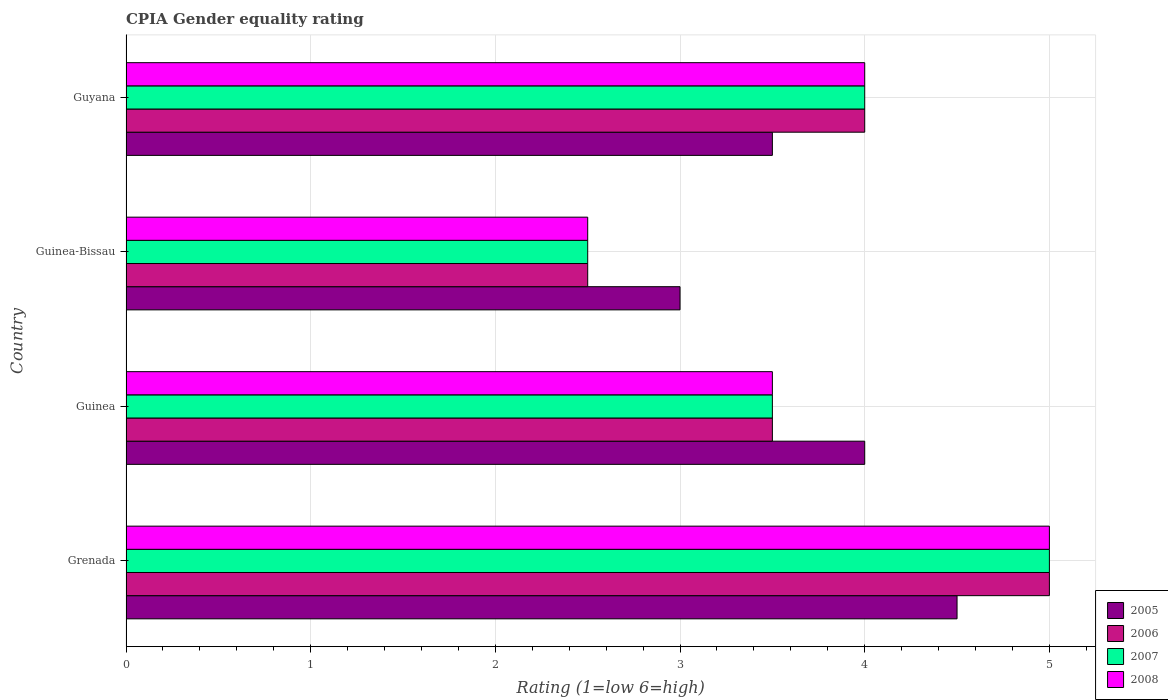How many different coloured bars are there?
Offer a very short reply. 4. How many groups of bars are there?
Ensure brevity in your answer.  4. How many bars are there on the 2nd tick from the bottom?
Make the answer very short. 4. What is the label of the 4th group of bars from the top?
Offer a terse response. Grenada. Across all countries, what is the maximum CPIA rating in 2005?
Make the answer very short. 4.5. In which country was the CPIA rating in 2005 maximum?
Offer a very short reply. Grenada. In which country was the CPIA rating in 2007 minimum?
Give a very brief answer. Guinea-Bissau. What is the total CPIA rating in 2005 in the graph?
Offer a terse response. 15. What is the average CPIA rating in 2007 per country?
Offer a terse response. 3.75. What is the difference between the CPIA rating in 2005 and CPIA rating in 2006 in Guinea?
Ensure brevity in your answer.  0.5. In how many countries, is the CPIA rating in 2006 greater than 1 ?
Offer a terse response. 4. Is the difference between the CPIA rating in 2005 in Grenada and Guinea greater than the difference between the CPIA rating in 2006 in Grenada and Guinea?
Provide a succinct answer. No. What is the difference between the highest and the second highest CPIA rating in 2008?
Your response must be concise. 1. What is the difference between the highest and the lowest CPIA rating in 2006?
Your answer should be very brief. 2.5. In how many countries, is the CPIA rating in 2008 greater than the average CPIA rating in 2008 taken over all countries?
Offer a terse response. 2. What does the 3rd bar from the top in Guinea represents?
Provide a succinct answer. 2006. What does the 1st bar from the bottom in Guinea-Bissau represents?
Make the answer very short. 2005. Is it the case that in every country, the sum of the CPIA rating in 2008 and CPIA rating in 2005 is greater than the CPIA rating in 2006?
Provide a succinct answer. Yes. How many bars are there?
Ensure brevity in your answer.  16. Are all the bars in the graph horizontal?
Keep it short and to the point. Yes. How many countries are there in the graph?
Your answer should be very brief. 4. Does the graph contain any zero values?
Offer a terse response. No. Does the graph contain grids?
Provide a short and direct response. Yes. Where does the legend appear in the graph?
Make the answer very short. Bottom right. How are the legend labels stacked?
Ensure brevity in your answer.  Vertical. What is the title of the graph?
Your response must be concise. CPIA Gender equality rating. Does "2007" appear as one of the legend labels in the graph?
Ensure brevity in your answer.  Yes. What is the label or title of the X-axis?
Ensure brevity in your answer.  Rating (1=low 6=high). What is the Rating (1=low 6=high) of 2007 in Grenada?
Give a very brief answer. 5. What is the Rating (1=low 6=high) in 2008 in Grenada?
Keep it short and to the point. 5. What is the Rating (1=low 6=high) of 2007 in Guinea?
Ensure brevity in your answer.  3.5. What is the Rating (1=low 6=high) of 2008 in Guinea?
Offer a terse response. 3.5. What is the Rating (1=low 6=high) in 2005 in Guinea-Bissau?
Ensure brevity in your answer.  3. What is the Rating (1=low 6=high) in 2006 in Guinea-Bissau?
Keep it short and to the point. 2.5. What is the Rating (1=low 6=high) in 2006 in Guyana?
Provide a succinct answer. 4. Across all countries, what is the maximum Rating (1=low 6=high) of 2006?
Your answer should be very brief. 5. Across all countries, what is the maximum Rating (1=low 6=high) of 2007?
Provide a succinct answer. 5. Across all countries, what is the maximum Rating (1=low 6=high) of 2008?
Give a very brief answer. 5. Across all countries, what is the minimum Rating (1=low 6=high) of 2006?
Your answer should be compact. 2.5. Across all countries, what is the minimum Rating (1=low 6=high) in 2007?
Offer a terse response. 2.5. What is the total Rating (1=low 6=high) in 2005 in the graph?
Keep it short and to the point. 15. What is the total Rating (1=low 6=high) of 2006 in the graph?
Your answer should be compact. 15. What is the total Rating (1=low 6=high) of 2007 in the graph?
Give a very brief answer. 15. What is the difference between the Rating (1=low 6=high) of 2005 in Grenada and that in Guinea?
Ensure brevity in your answer.  0.5. What is the difference between the Rating (1=low 6=high) of 2006 in Grenada and that in Guinea?
Give a very brief answer. 1.5. What is the difference between the Rating (1=low 6=high) in 2005 in Grenada and that in Guyana?
Give a very brief answer. 1. What is the difference between the Rating (1=low 6=high) of 2007 in Grenada and that in Guyana?
Offer a terse response. 1. What is the difference between the Rating (1=low 6=high) of 2005 in Guinea and that in Guinea-Bissau?
Offer a very short reply. 1. What is the difference between the Rating (1=low 6=high) of 2006 in Guinea and that in Guinea-Bissau?
Provide a short and direct response. 1. What is the difference between the Rating (1=low 6=high) of 2007 in Guinea and that in Guinea-Bissau?
Give a very brief answer. 1. What is the difference between the Rating (1=low 6=high) of 2008 in Guinea and that in Guinea-Bissau?
Offer a very short reply. 1. What is the difference between the Rating (1=low 6=high) of 2007 in Guinea and that in Guyana?
Offer a very short reply. -0.5. What is the difference between the Rating (1=low 6=high) of 2005 in Guinea-Bissau and that in Guyana?
Offer a terse response. -0.5. What is the difference between the Rating (1=low 6=high) of 2007 in Guinea-Bissau and that in Guyana?
Your answer should be very brief. -1.5. What is the difference between the Rating (1=low 6=high) in 2008 in Guinea-Bissau and that in Guyana?
Your answer should be compact. -1.5. What is the difference between the Rating (1=low 6=high) in 2005 in Grenada and the Rating (1=low 6=high) in 2006 in Guinea?
Offer a very short reply. 1. What is the difference between the Rating (1=low 6=high) of 2005 in Grenada and the Rating (1=low 6=high) of 2007 in Guinea?
Give a very brief answer. 1. What is the difference between the Rating (1=low 6=high) in 2007 in Grenada and the Rating (1=low 6=high) in 2008 in Guinea?
Offer a terse response. 1.5. What is the difference between the Rating (1=low 6=high) of 2006 in Grenada and the Rating (1=low 6=high) of 2008 in Guinea-Bissau?
Your answer should be compact. 2.5. What is the difference between the Rating (1=low 6=high) in 2005 in Grenada and the Rating (1=low 6=high) in 2006 in Guyana?
Give a very brief answer. 0.5. What is the difference between the Rating (1=low 6=high) of 2006 in Grenada and the Rating (1=low 6=high) of 2007 in Guyana?
Offer a very short reply. 1. What is the difference between the Rating (1=low 6=high) in 2006 in Grenada and the Rating (1=low 6=high) in 2008 in Guyana?
Offer a very short reply. 1. What is the difference between the Rating (1=low 6=high) in 2005 in Guinea and the Rating (1=low 6=high) in 2006 in Guinea-Bissau?
Your response must be concise. 1.5. What is the difference between the Rating (1=low 6=high) in 2005 in Guinea and the Rating (1=low 6=high) in 2007 in Guinea-Bissau?
Give a very brief answer. 1.5. What is the difference between the Rating (1=low 6=high) in 2006 in Guinea and the Rating (1=low 6=high) in 2008 in Guinea-Bissau?
Provide a succinct answer. 1. What is the difference between the Rating (1=low 6=high) of 2005 in Guinea and the Rating (1=low 6=high) of 2006 in Guyana?
Provide a succinct answer. 0. What is the difference between the Rating (1=low 6=high) in 2005 in Guinea and the Rating (1=low 6=high) in 2007 in Guyana?
Provide a succinct answer. 0. What is the difference between the Rating (1=low 6=high) in 2005 in Guinea and the Rating (1=low 6=high) in 2008 in Guyana?
Make the answer very short. 0. What is the difference between the Rating (1=low 6=high) in 2005 in Guinea-Bissau and the Rating (1=low 6=high) in 2006 in Guyana?
Give a very brief answer. -1. What is the difference between the Rating (1=low 6=high) in 2005 in Guinea-Bissau and the Rating (1=low 6=high) in 2007 in Guyana?
Offer a very short reply. -1. What is the difference between the Rating (1=low 6=high) in 2005 in Guinea-Bissau and the Rating (1=low 6=high) in 2008 in Guyana?
Give a very brief answer. -1. What is the difference between the Rating (1=low 6=high) in 2007 in Guinea-Bissau and the Rating (1=low 6=high) in 2008 in Guyana?
Make the answer very short. -1.5. What is the average Rating (1=low 6=high) of 2005 per country?
Offer a terse response. 3.75. What is the average Rating (1=low 6=high) of 2006 per country?
Provide a succinct answer. 3.75. What is the average Rating (1=low 6=high) of 2007 per country?
Your response must be concise. 3.75. What is the average Rating (1=low 6=high) of 2008 per country?
Give a very brief answer. 3.75. What is the difference between the Rating (1=low 6=high) in 2005 and Rating (1=low 6=high) in 2006 in Grenada?
Offer a terse response. -0.5. What is the difference between the Rating (1=low 6=high) of 2007 and Rating (1=low 6=high) of 2008 in Grenada?
Make the answer very short. 0. What is the difference between the Rating (1=low 6=high) in 2005 and Rating (1=low 6=high) in 2007 in Guinea?
Ensure brevity in your answer.  0.5. What is the difference between the Rating (1=low 6=high) in 2006 and Rating (1=low 6=high) in 2007 in Guinea?
Offer a very short reply. 0. What is the difference between the Rating (1=low 6=high) in 2006 and Rating (1=low 6=high) in 2008 in Guinea?
Provide a short and direct response. 0. What is the difference between the Rating (1=low 6=high) of 2005 and Rating (1=low 6=high) of 2007 in Guinea-Bissau?
Offer a terse response. 0.5. What is the difference between the Rating (1=low 6=high) of 2006 and Rating (1=low 6=high) of 2007 in Guinea-Bissau?
Your answer should be very brief. 0. What is the difference between the Rating (1=low 6=high) of 2005 and Rating (1=low 6=high) of 2006 in Guyana?
Ensure brevity in your answer.  -0.5. What is the difference between the Rating (1=low 6=high) in 2006 and Rating (1=low 6=high) in 2007 in Guyana?
Your response must be concise. 0. What is the ratio of the Rating (1=low 6=high) in 2005 in Grenada to that in Guinea?
Provide a succinct answer. 1.12. What is the ratio of the Rating (1=low 6=high) in 2006 in Grenada to that in Guinea?
Your answer should be very brief. 1.43. What is the ratio of the Rating (1=low 6=high) in 2007 in Grenada to that in Guinea?
Offer a terse response. 1.43. What is the ratio of the Rating (1=low 6=high) in 2008 in Grenada to that in Guinea?
Ensure brevity in your answer.  1.43. What is the ratio of the Rating (1=low 6=high) of 2005 in Grenada to that in Guinea-Bissau?
Offer a very short reply. 1.5. What is the ratio of the Rating (1=low 6=high) of 2007 in Grenada to that in Guinea-Bissau?
Your answer should be compact. 2. What is the ratio of the Rating (1=low 6=high) of 2008 in Grenada to that in Guinea-Bissau?
Offer a very short reply. 2. What is the ratio of the Rating (1=low 6=high) in 2005 in Grenada to that in Guyana?
Provide a short and direct response. 1.29. What is the ratio of the Rating (1=low 6=high) in 2006 in Grenada to that in Guyana?
Provide a short and direct response. 1.25. What is the ratio of the Rating (1=low 6=high) in 2005 in Guinea to that in Guinea-Bissau?
Your response must be concise. 1.33. What is the ratio of the Rating (1=low 6=high) in 2006 in Guinea to that in Guinea-Bissau?
Provide a short and direct response. 1.4. What is the ratio of the Rating (1=low 6=high) of 2008 in Guinea to that in Guinea-Bissau?
Provide a succinct answer. 1.4. What is the ratio of the Rating (1=low 6=high) of 2008 in Guinea to that in Guyana?
Offer a terse response. 0.88. What is the ratio of the Rating (1=low 6=high) of 2006 in Guinea-Bissau to that in Guyana?
Provide a short and direct response. 0.62. What is the difference between the highest and the second highest Rating (1=low 6=high) of 2005?
Your response must be concise. 0.5. What is the difference between the highest and the second highest Rating (1=low 6=high) in 2006?
Your response must be concise. 1. What is the difference between the highest and the lowest Rating (1=low 6=high) of 2005?
Your answer should be very brief. 1.5. What is the difference between the highest and the lowest Rating (1=low 6=high) in 2006?
Ensure brevity in your answer.  2.5. 